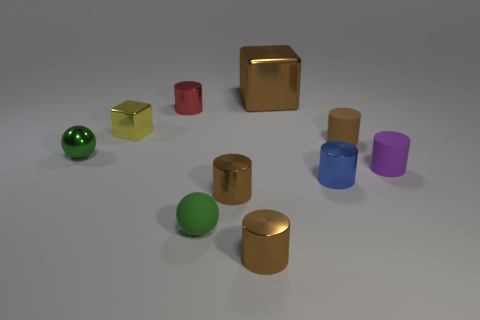Do the small red object behind the tiny green matte ball and the rubber object to the right of the brown matte cylinder have the same shape?
Your response must be concise. Yes. What number of things are tiny brown blocks or blue metal cylinders in front of the small purple matte object?
Provide a succinct answer. 1. How many other things are the same size as the yellow metallic object?
Your answer should be very brief. 8. Is the red thing that is on the left side of the small blue object made of the same material as the ball in front of the small purple matte cylinder?
Provide a succinct answer. No. What number of spheres are in front of the shiny sphere?
Provide a succinct answer. 1. What number of red things are either shiny cylinders or balls?
Offer a terse response. 1. What is the material of the blue thing that is the same size as the purple matte object?
Provide a short and direct response. Metal. The metallic object that is left of the small rubber ball and behind the small metallic cube has what shape?
Ensure brevity in your answer.  Cylinder. There is a metallic block that is the same size as the red thing; what color is it?
Ensure brevity in your answer.  Yellow. Is the size of the rubber thing that is in front of the blue cylinder the same as the metallic thing on the right side of the brown cube?
Offer a terse response. Yes. 